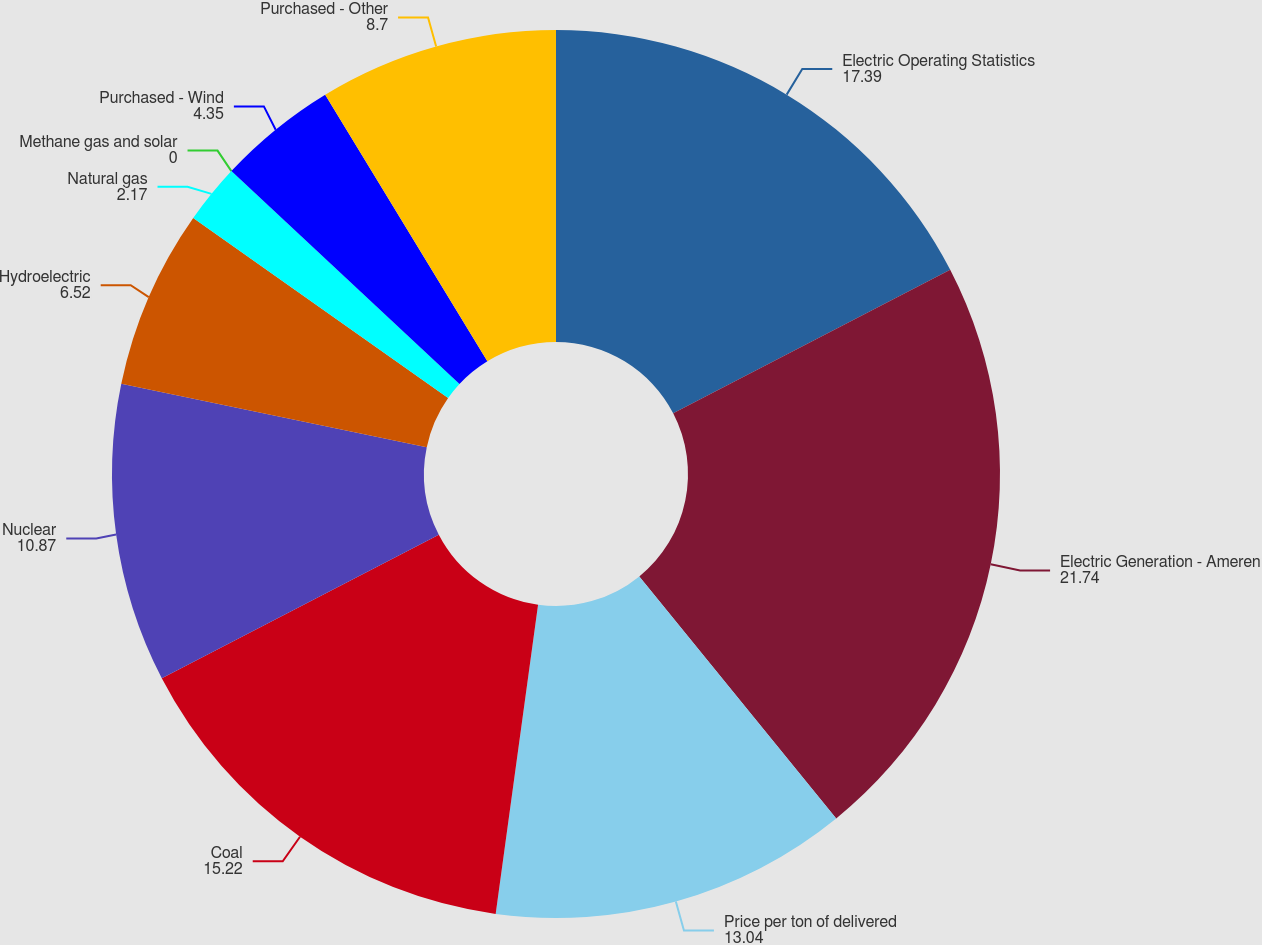Convert chart. <chart><loc_0><loc_0><loc_500><loc_500><pie_chart><fcel>Electric Operating Statistics<fcel>Electric Generation - Ameren<fcel>Price per ton of delivered<fcel>Coal<fcel>Nuclear<fcel>Hydroelectric<fcel>Natural gas<fcel>Methane gas and solar<fcel>Purchased - Wind<fcel>Purchased - Other<nl><fcel>17.39%<fcel>21.74%<fcel>13.04%<fcel>15.22%<fcel>10.87%<fcel>6.52%<fcel>2.17%<fcel>0.0%<fcel>4.35%<fcel>8.7%<nl></chart> 